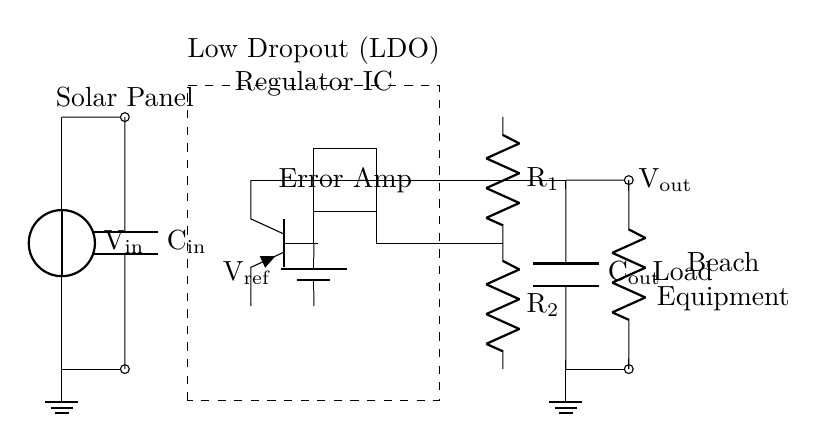What is the input voltage source labeled as? The input voltage source is labeled as "V_in," indicating it is the voltage supplied to the circuit.
Answer: V_in What type of regulator is shown in the circuit? The circuit shows a low dropout (LDO) regulator. This is indicated by the description in the dashed rectangle.
Answer: LDO What does the load represent in the circuit? The load is represented by a resistor labeled "Load," which is the component that consumes power from the regulator output.
Answer: Load What is the role of the error amplifier in this circuit? The error amplifier ensures that the output voltage remains constant by comparing it with a reference voltage and adjusting the pass transistor accordingly.
Answer: Regulation What is the reference voltage labeled as? The reference voltage is labeled as "V_ref" in the circuit, which is used by the error amplifier for comparison with the output voltage.
Answer: V_ref How many capacitors are used in this regulator circuit and what are they labeled? There are two capacitors: one labeled "C_in" for the input and another labeled "C_out" for the output, which stabilize the voltage.
Answer: C_in, C_out What are the resistor values in the feedback network? The resistors in the feedback network are labeled "R1" and "R2," which help set the output voltage of the regulator based on the feedback from the output.
Answer: R1, R2 